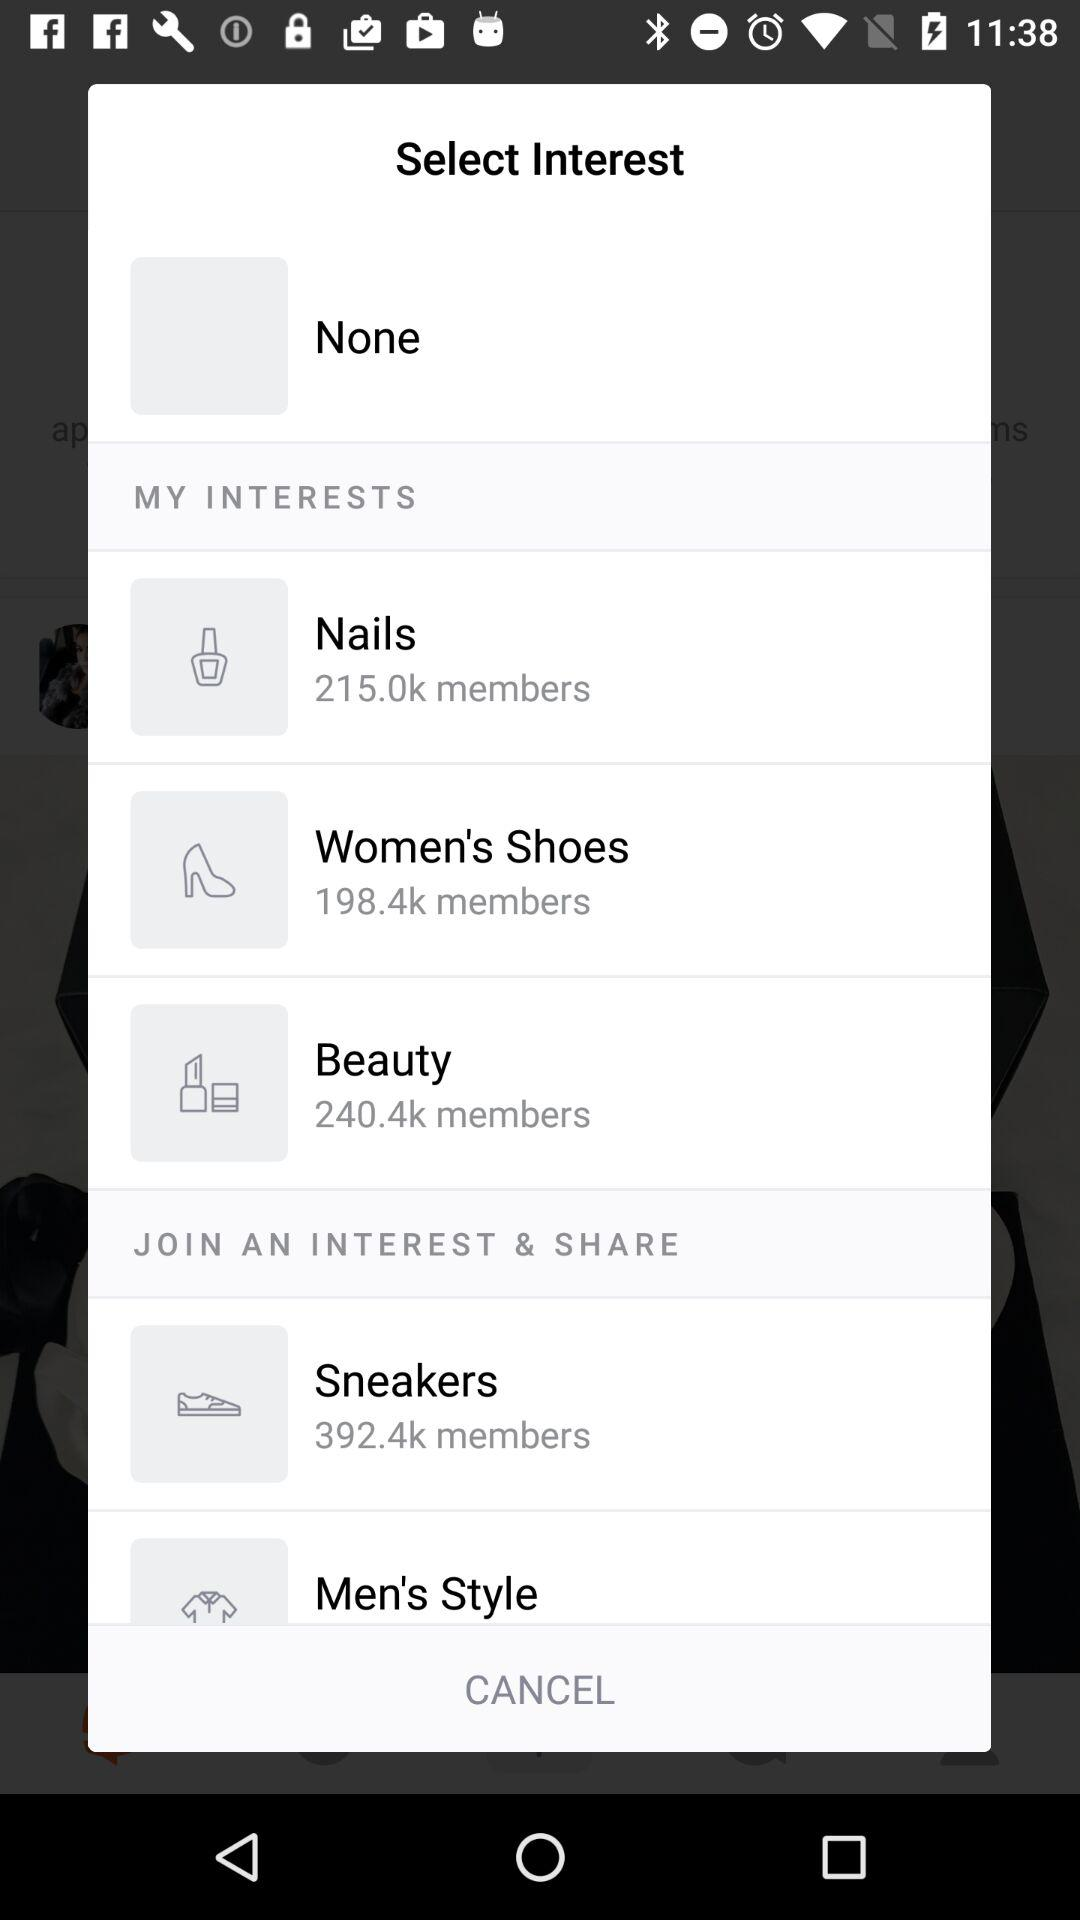How many members have shown an interest in "Nails"? The number of members that have shown an interest in "Nails" is 215.0k. 